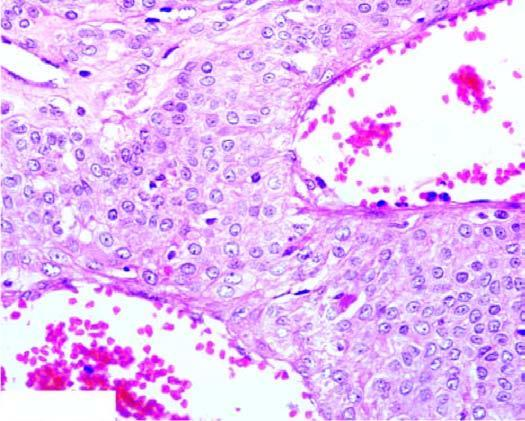what are blood-filled vascular channels lined by?
Answer the question using a single word or phrase. Endothelial cells and surrounded by nests and masses of glomus cells 